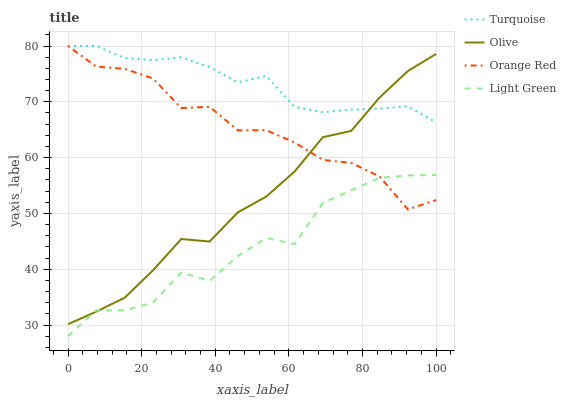Does Light Green have the minimum area under the curve?
Answer yes or no. Yes. Does Turquoise have the maximum area under the curve?
Answer yes or no. Yes. Does Orange Red have the minimum area under the curve?
Answer yes or no. No. Does Orange Red have the maximum area under the curve?
Answer yes or no. No. Is Turquoise the smoothest?
Answer yes or no. Yes. Is Light Green the roughest?
Answer yes or no. Yes. Is Orange Red the smoothest?
Answer yes or no. No. Is Orange Red the roughest?
Answer yes or no. No. Does Light Green have the lowest value?
Answer yes or no. Yes. Does Orange Red have the lowest value?
Answer yes or no. No. Does Orange Red have the highest value?
Answer yes or no. Yes. Does Light Green have the highest value?
Answer yes or no. No. Is Light Green less than Turquoise?
Answer yes or no. Yes. Is Turquoise greater than Light Green?
Answer yes or no. Yes. Does Light Green intersect Olive?
Answer yes or no. Yes. Is Light Green less than Olive?
Answer yes or no. No. Is Light Green greater than Olive?
Answer yes or no. No. Does Light Green intersect Turquoise?
Answer yes or no. No. 